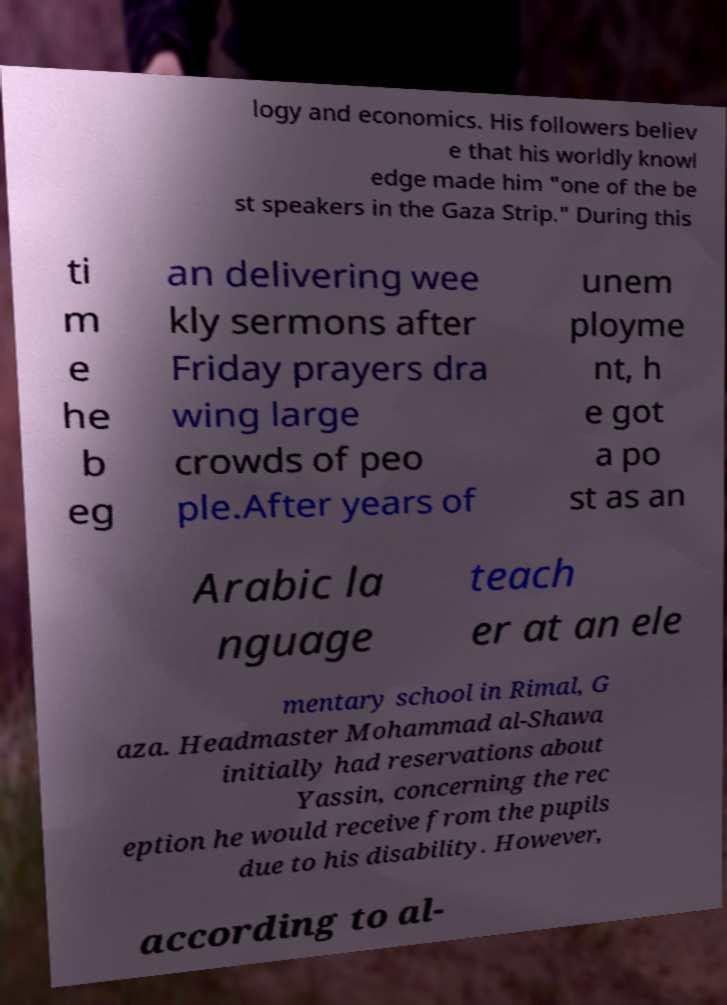Could you assist in decoding the text presented in this image and type it out clearly? logy and economics. His followers believ e that his worldly knowl edge made him "one of the be st speakers in the Gaza Strip." During this ti m e he b eg an delivering wee kly sermons after Friday prayers dra wing large crowds of peo ple.After years of unem ployme nt, h e got a po st as an Arabic la nguage teach er at an ele mentary school in Rimal, G aza. Headmaster Mohammad al-Shawa initially had reservations about Yassin, concerning the rec eption he would receive from the pupils due to his disability. However, according to al- 